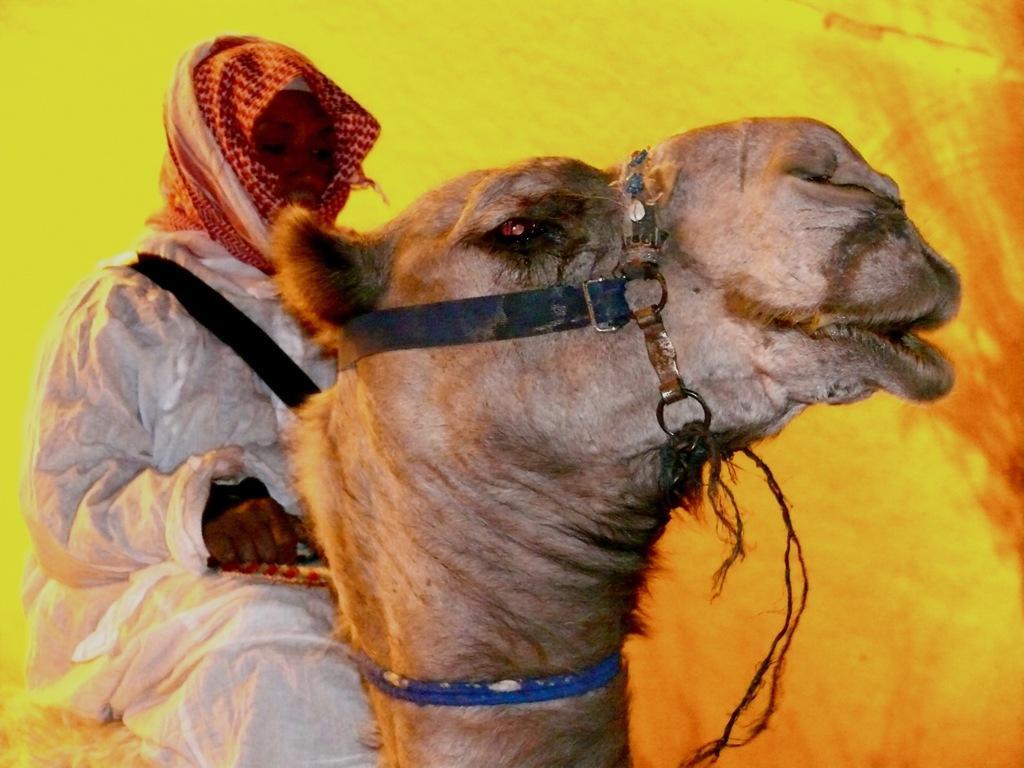Describe this image in one or two sentences. In this image we can see a person is sitting on the camel. In the background of the image is in yellow color. 